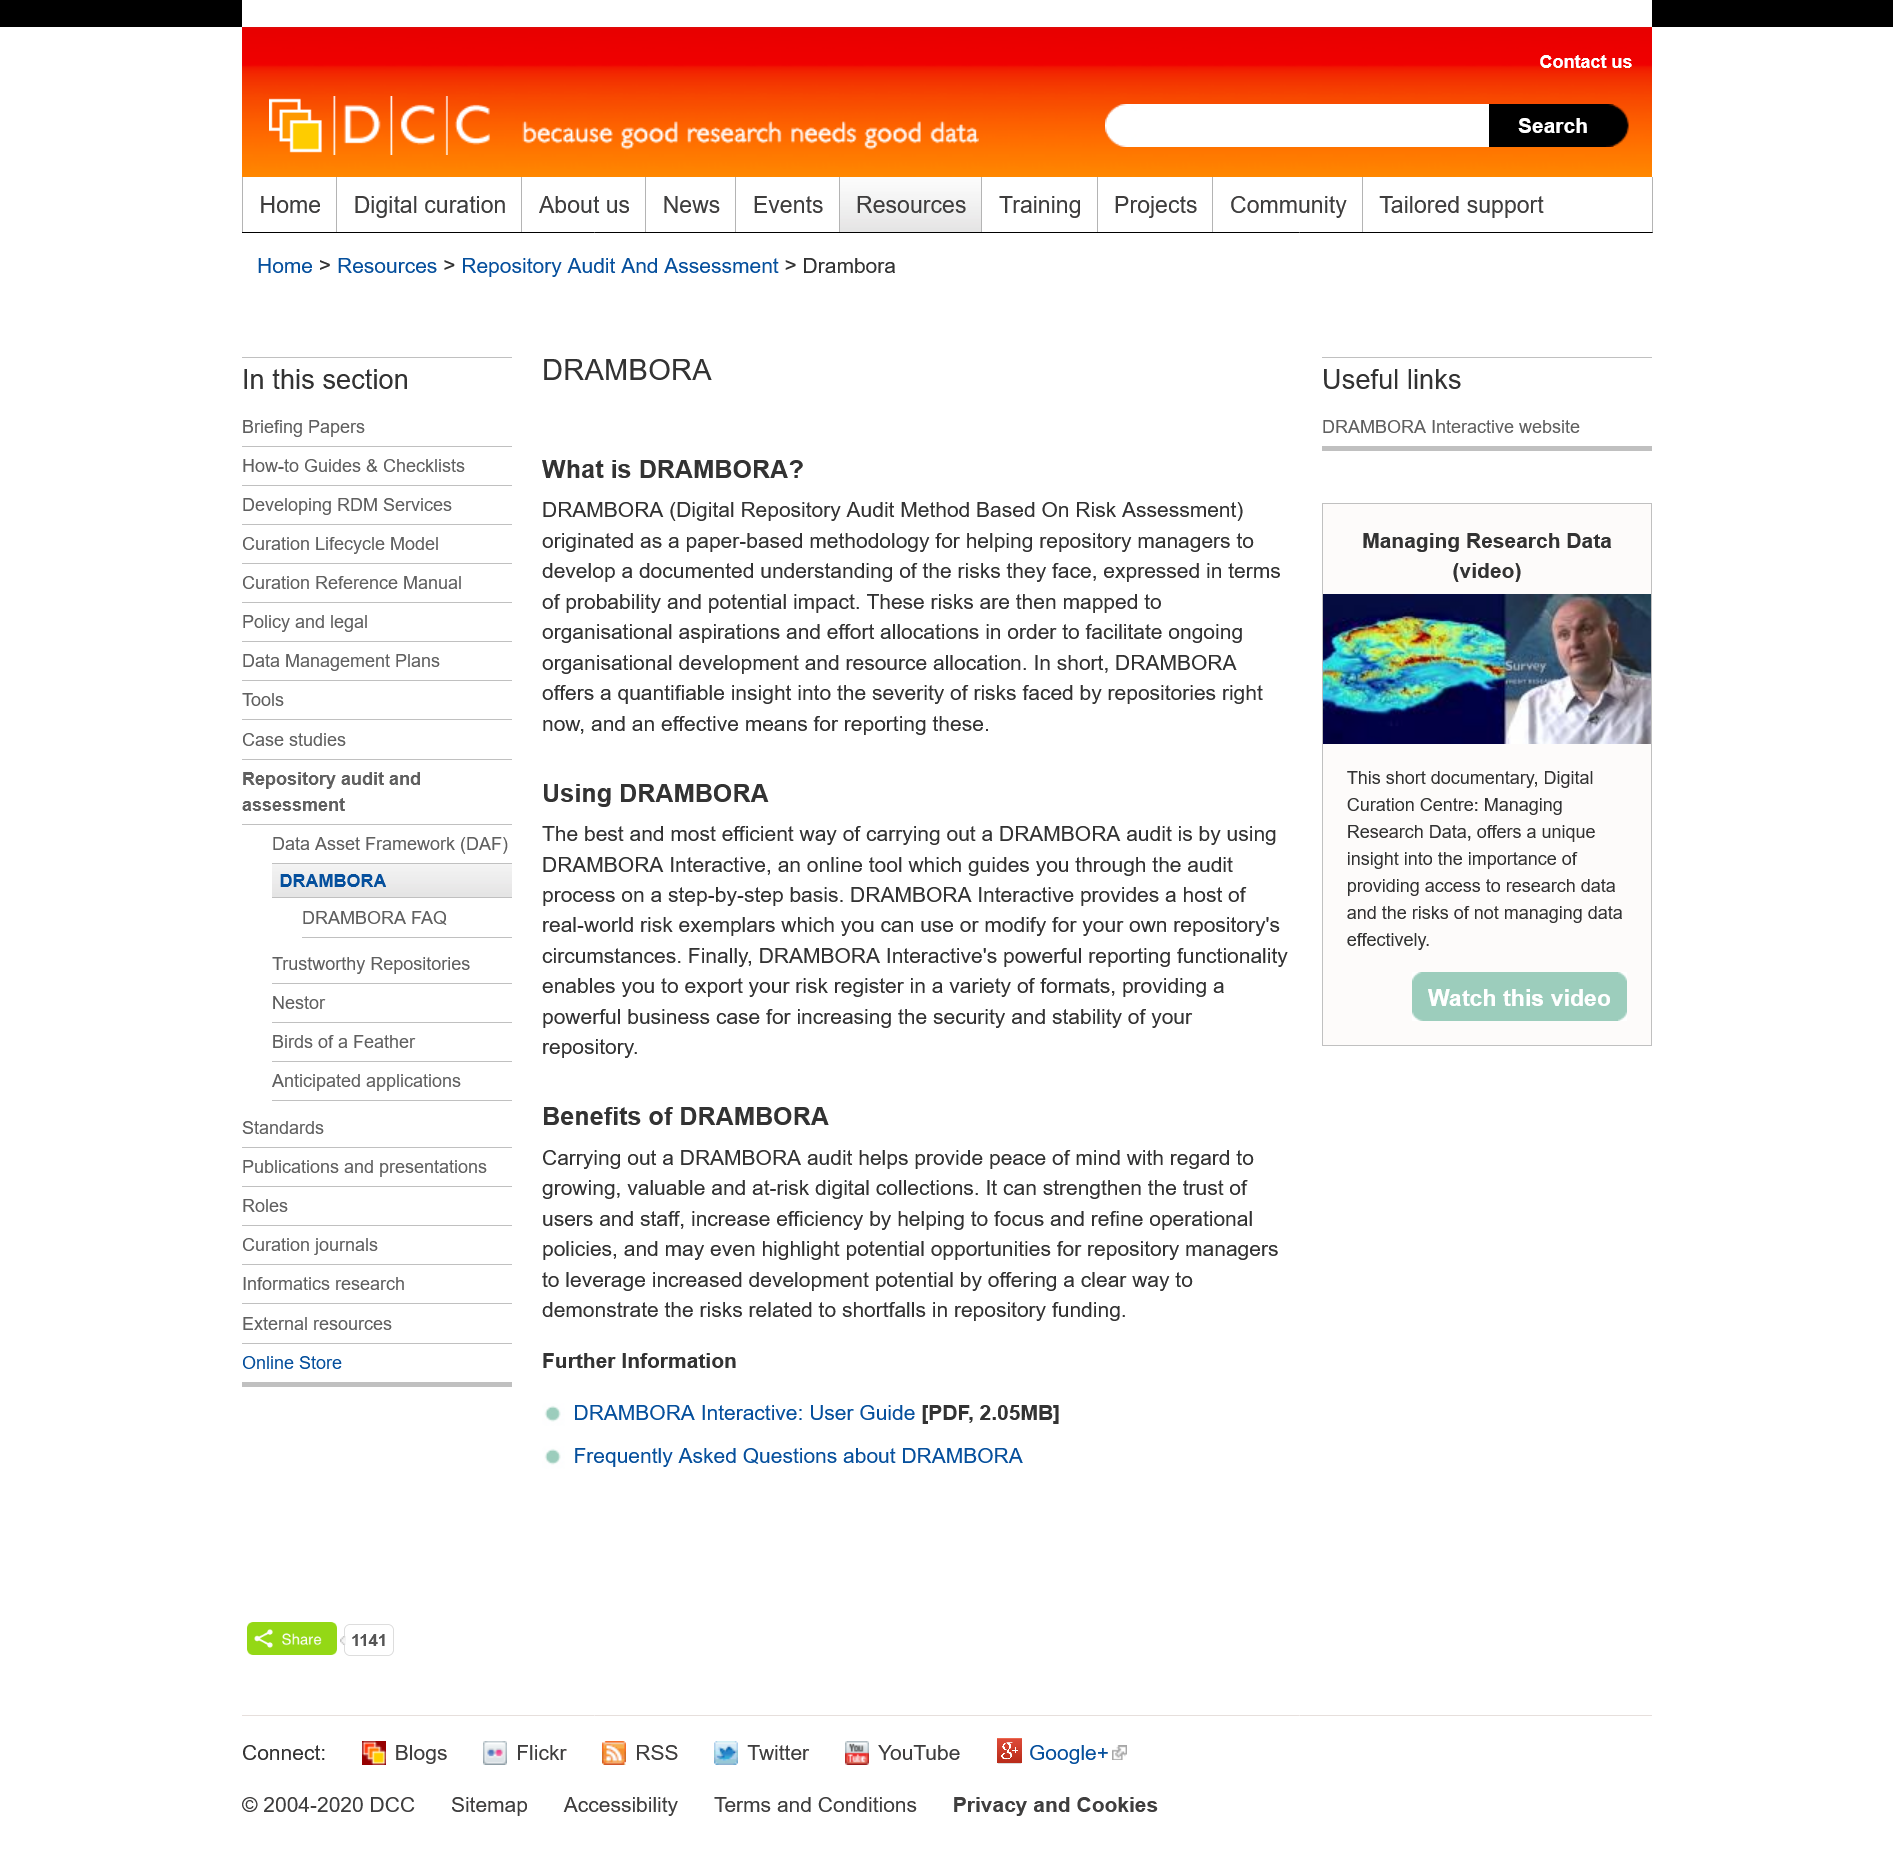Draw attention to some important aspects in this diagram. The title of the page is "Benefits of DRAMBORA". Yes, DRAMBORA provides a means for reporting risks. DRAMBORA Interactive is an online tool that guides users through the audit process in a step-by-step manner. DRAMBORA Interactive offers a variety of real-world risk examples that can be customized to fit the specific needs of your repository. DRAMBORA stands for Digital Repository Audit Method Based On Risk Assessment. 